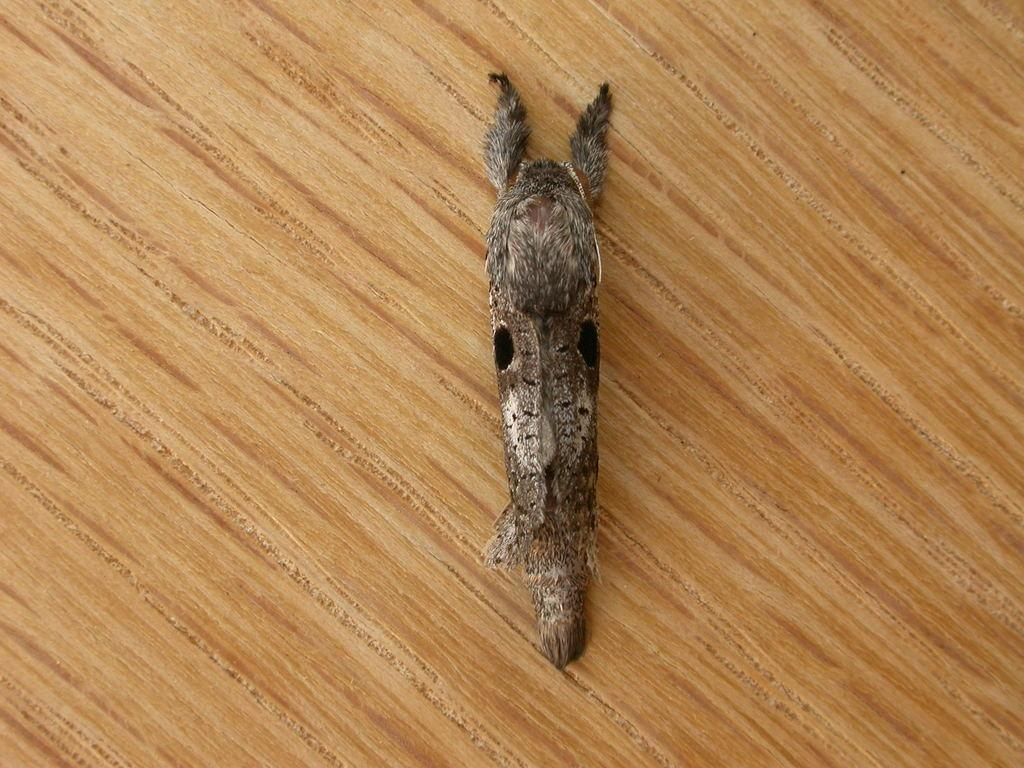What type of creature can be seen in the image? There is an insect in the image. Where is the insect located? The insect is on a wooden block. How many children are playing with the berries on the boats in the image? There are no children, berries, or boats present in the image; it only features an insect on a wooden block. 